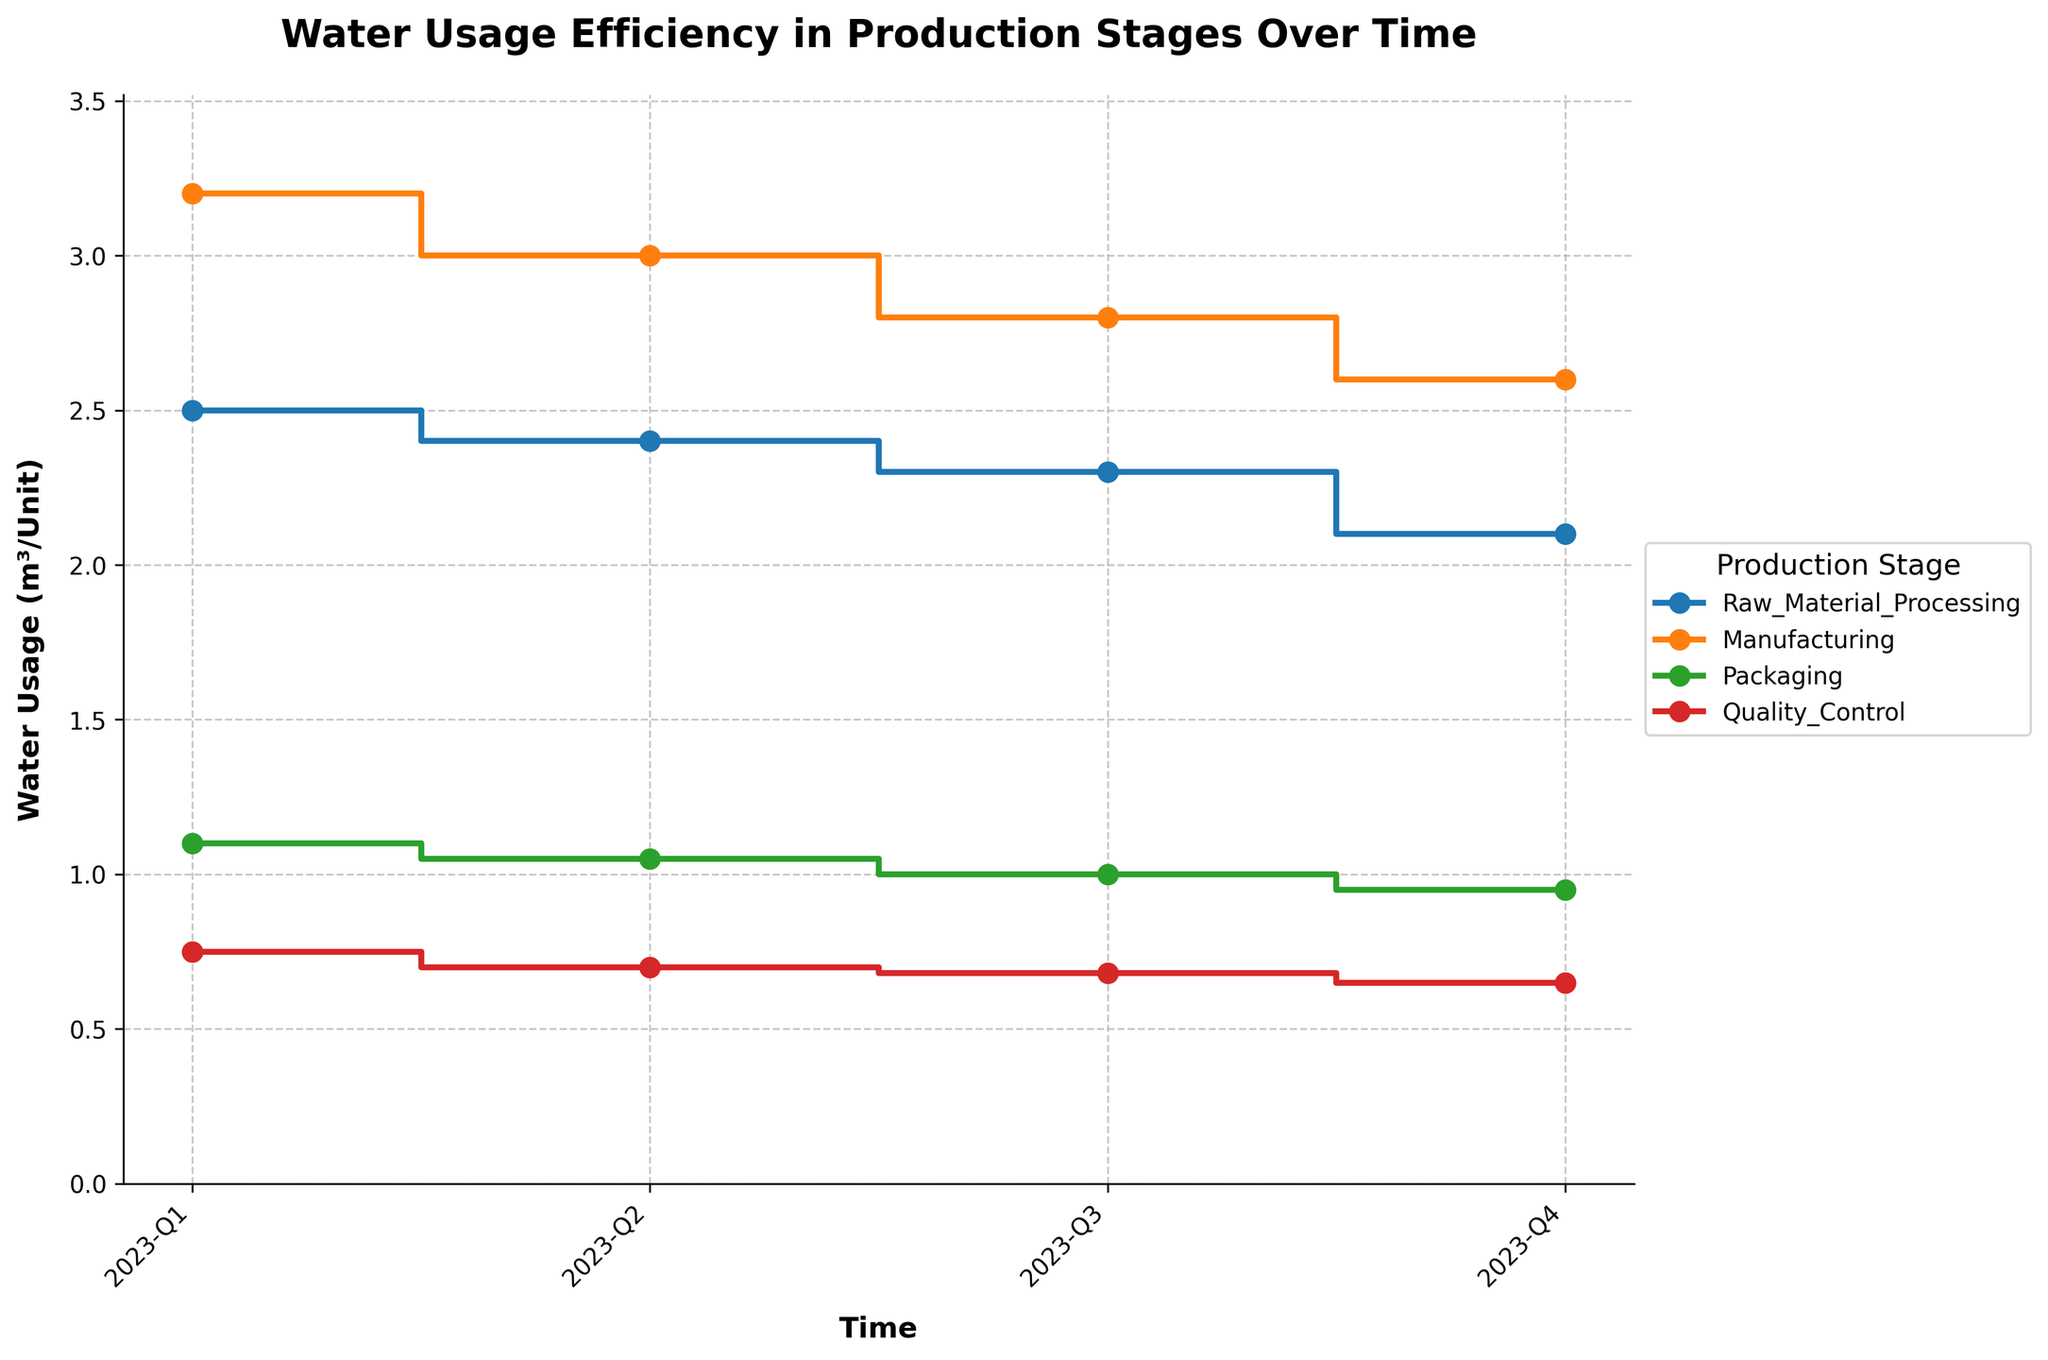What's the title of the plot? The title is placed at the top of the plot in bold, large font. It reads "Water Usage Efficiency in Production Stages Over Time".
Answer: Water Usage Efficiency in Production Stages Over Time What is the water usage in the Raw Material Processing stage in 2023-Q1? Follow the line corresponding to the Raw Material Processing stage to the point marked at the 2023-Q1 time period, then read the value on the y-axis, which is 2.5 m³/Unit.
Answer: 2.5 m³/Unit Which production stage had the highest water usage in 2023-Q4? Look for the highest point on the y-axis for the 2023-Q4 time period and identify the corresponding line's label. The highest value in 2023-Q4 is for Manufacturing at 2.6 m³/Unit.
Answer: Manufacturing What is the average water usage across the Manufacturing stage from 2023-Q1 to 2023-Q4? Sum the water usage values for the Manufacturing stage over the four quarters and divide by the number of quarters. (3.2 + 3.0 + 2.8 + 2.6)/4 = 2.9 m³/Unit.
Answer: 2.9 m³/Unit What is the difference in water usage between 2023-Q1 and 2023-Q4 for Quality Control? Subtract the water usage value in 2023-Q4 from that in 2023-Q1 for the Quality Control stage. 0.75 - 0.65 = 0.10 m³/Unit.
Answer: 0.10 m³/Unit Which time period shows a consistent decline in water usage for all production stages? Check each production stage's trend across all quarters to see if the water usage consistently decreases. From 2023-Q1 to 2023-Q4, all stages show a consistent decline.
Answer: 2023-Q1 to 2023-Q4 How does the water usage in Packaging compare between 2023-Q2 and 2023-Q3? Observe the water usage values for Packaging in 2023-Q2 and 2023-Q3 and make a comparison. The value decreases from 1.05 m³/Unit in Q2 to 1.00 m³/Unit in Q3.
Answer: Decreases What's the trend in water usage for Raw Material Processing from 2023-Q1 to 2023-Q4? Follow the line for Raw Material Processing and note the direction of the values from 2023-Q1 to 2023-Q4, which show a consistent downward trend.
Answer: Downward trend Identify the production stage with the smallest change in water usage from 2023-Q1 to 2023-Q4. Calculate the difference in water usage for each stage from 2023-Q1 to 2023-Q4, then find the smallest change. Packaging changes from 1.1 to 0.95, a difference of 0.15, which is the smallest change.
Answer: Packaging 